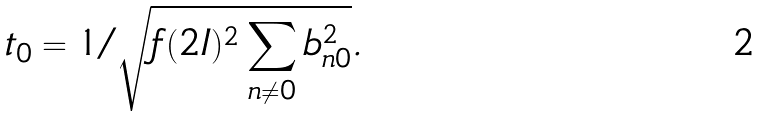Convert formula to latex. <formula><loc_0><loc_0><loc_500><loc_500>t _ { 0 } = 1 / \sqrt { f ( 2 I ) ^ { 2 } \sum _ { n \ne 0 } b _ { n 0 } ^ { 2 } } .</formula> 